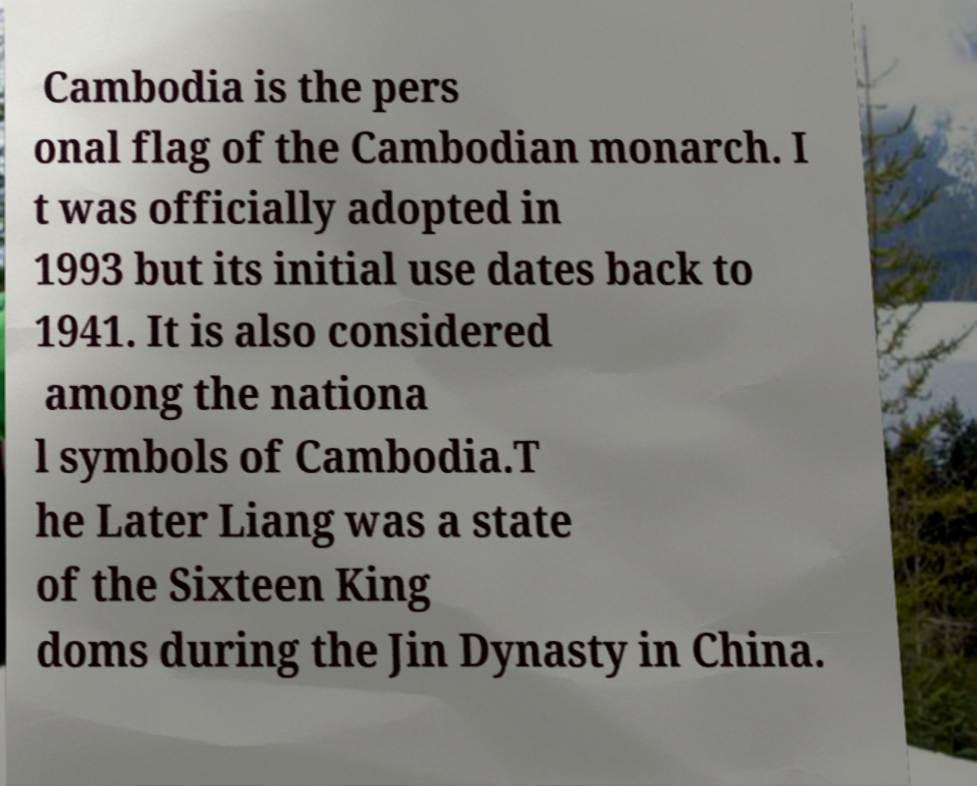Can you read and provide the text displayed in the image?This photo seems to have some interesting text. Can you extract and type it out for me? Cambodia is the pers onal flag of the Cambodian monarch. I t was officially adopted in 1993 but its initial use dates back to 1941. It is also considered among the nationa l symbols of Cambodia.T he Later Liang was a state of the Sixteen King doms during the Jin Dynasty in China. 